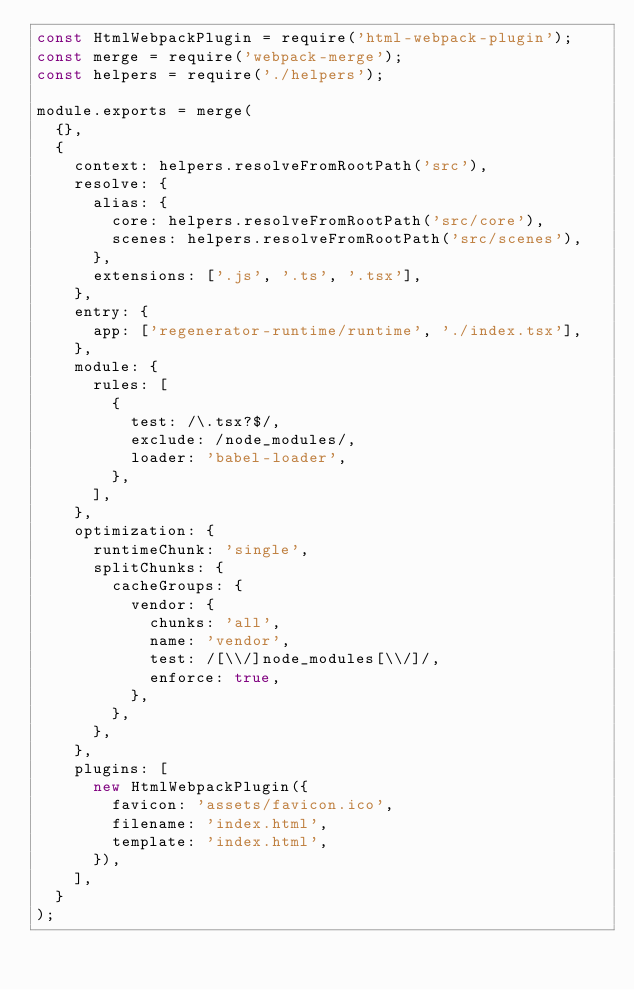Convert code to text. <code><loc_0><loc_0><loc_500><loc_500><_JavaScript_>const HtmlWebpackPlugin = require('html-webpack-plugin');
const merge = require('webpack-merge');
const helpers = require('./helpers');

module.exports = merge(
  {},
  {
    context: helpers.resolveFromRootPath('src'),
    resolve: {
      alias: {
        core: helpers.resolveFromRootPath('src/core'),
        scenes: helpers.resolveFromRootPath('src/scenes'),
      },
      extensions: ['.js', '.ts', '.tsx'],
    },
    entry: {
      app: ['regenerator-runtime/runtime', './index.tsx'],
    },
    module: {
      rules: [
        {
          test: /\.tsx?$/,
          exclude: /node_modules/,
          loader: 'babel-loader',
        },
      ],
    },
    optimization: {
      runtimeChunk: 'single',
      splitChunks: {
        cacheGroups: {
          vendor: {
            chunks: 'all',
            name: 'vendor',
            test: /[\\/]node_modules[\\/]/,
            enforce: true,
          },
        },
      },
    },
    plugins: [
      new HtmlWebpackPlugin({
        favicon: 'assets/favicon.ico',
        filename: 'index.html',
        template: 'index.html',
      }),
    ],
  }
);
</code> 